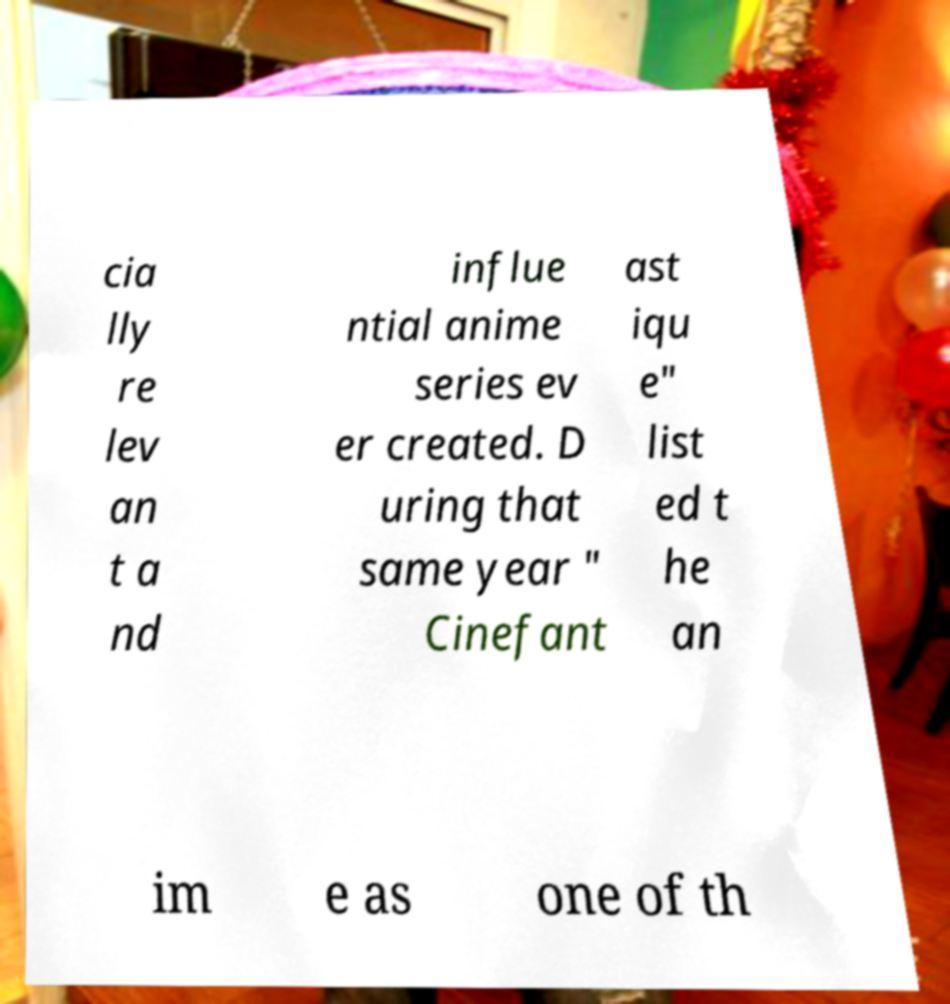There's text embedded in this image that I need extracted. Can you transcribe it verbatim? cia lly re lev an t a nd influe ntial anime series ev er created. D uring that same year " Cinefant ast iqu e" list ed t he an im e as one of th 